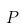Convert formula to latex. <formula><loc_0><loc_0><loc_500><loc_500>P</formula> 